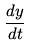Convert formula to latex. <formula><loc_0><loc_0><loc_500><loc_500>\frac { d y } { d t }</formula> 